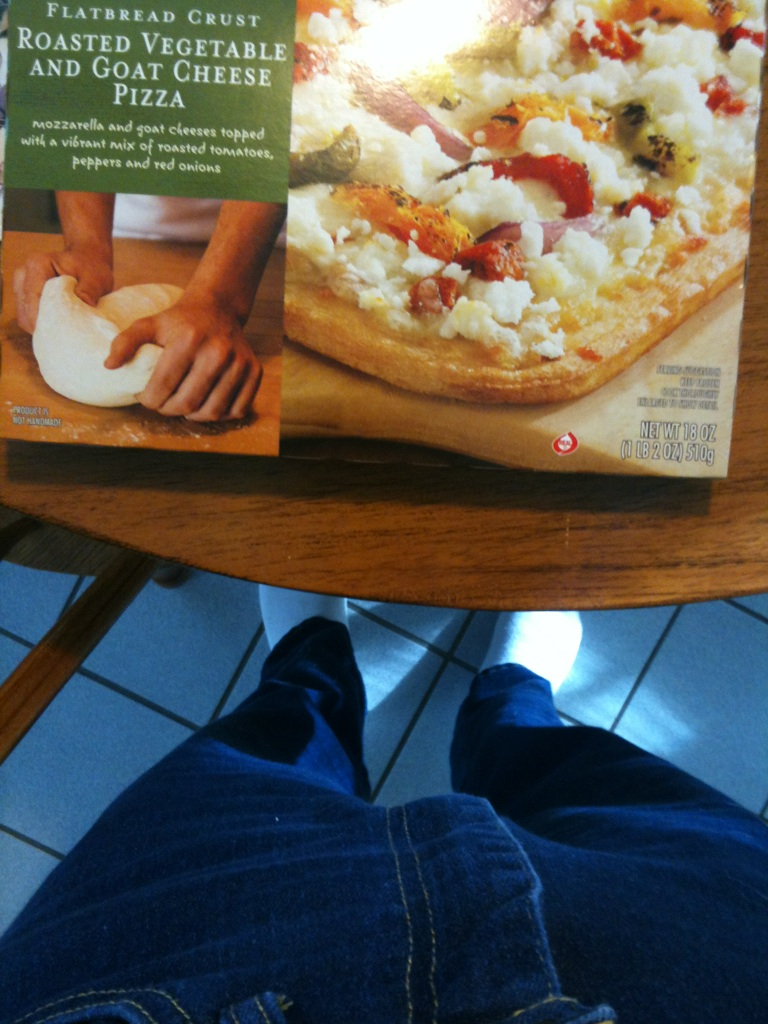what pizza is this? from Vizwiz roasted vegetable goat cheese 